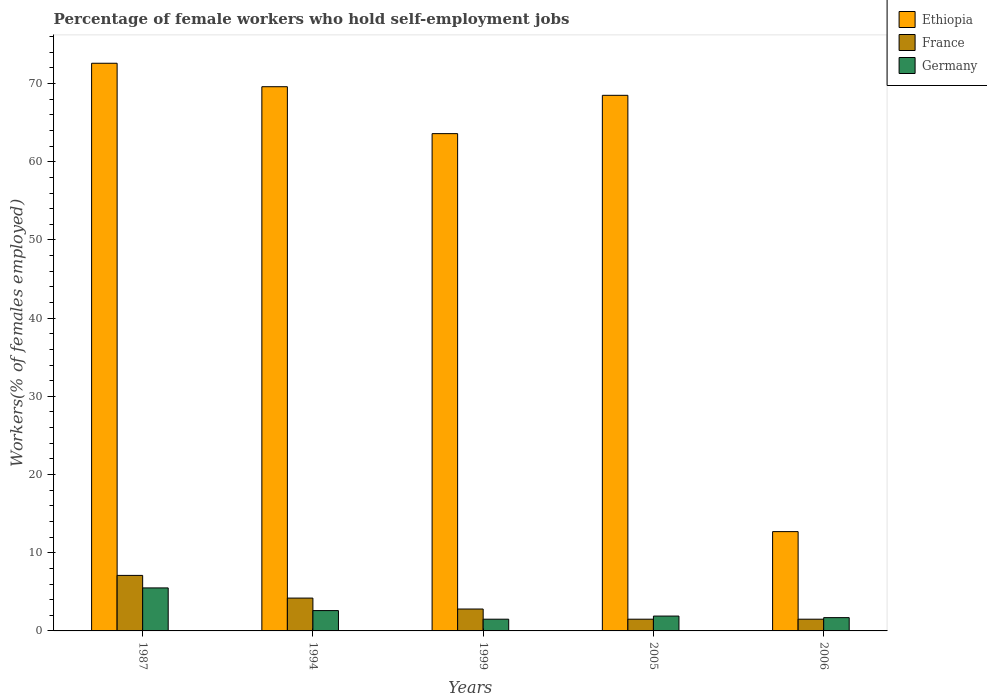How many groups of bars are there?
Offer a very short reply. 5. How many bars are there on the 4th tick from the left?
Make the answer very short. 3. How many bars are there on the 2nd tick from the right?
Offer a very short reply. 3. What is the percentage of self-employed female workers in Germany in 2005?
Provide a succinct answer. 1.9. Across all years, what is the maximum percentage of self-employed female workers in Ethiopia?
Keep it short and to the point. 72.6. Across all years, what is the minimum percentage of self-employed female workers in Ethiopia?
Provide a succinct answer. 12.7. In which year was the percentage of self-employed female workers in Ethiopia maximum?
Provide a succinct answer. 1987. In which year was the percentage of self-employed female workers in Germany minimum?
Provide a succinct answer. 1999. What is the total percentage of self-employed female workers in Germany in the graph?
Your answer should be very brief. 13.2. What is the difference between the percentage of self-employed female workers in France in 1994 and that in 2006?
Provide a succinct answer. 2.7. What is the difference between the percentage of self-employed female workers in Germany in 2006 and the percentage of self-employed female workers in Ethiopia in 1999?
Your answer should be compact. -61.9. What is the average percentage of self-employed female workers in Germany per year?
Your response must be concise. 2.64. In the year 1999, what is the difference between the percentage of self-employed female workers in Germany and percentage of self-employed female workers in Ethiopia?
Your answer should be compact. -62.1. What is the ratio of the percentage of self-employed female workers in Germany in 2005 to that in 2006?
Keep it short and to the point. 1.12. Is the percentage of self-employed female workers in Ethiopia in 1987 less than that in 1994?
Give a very brief answer. No. What is the difference between the highest and the second highest percentage of self-employed female workers in France?
Provide a short and direct response. 2.9. What is the difference between the highest and the lowest percentage of self-employed female workers in Germany?
Provide a short and direct response. 4. What does the 1st bar from the left in 2005 represents?
Your answer should be compact. Ethiopia. What does the 1st bar from the right in 1987 represents?
Give a very brief answer. Germany. What is the difference between two consecutive major ticks on the Y-axis?
Offer a very short reply. 10. Are the values on the major ticks of Y-axis written in scientific E-notation?
Provide a short and direct response. No. Does the graph contain any zero values?
Offer a very short reply. No. Does the graph contain grids?
Provide a succinct answer. No. How many legend labels are there?
Your answer should be very brief. 3. What is the title of the graph?
Give a very brief answer. Percentage of female workers who hold self-employment jobs. Does "Qatar" appear as one of the legend labels in the graph?
Your answer should be very brief. No. What is the label or title of the Y-axis?
Your response must be concise. Workers(% of females employed). What is the Workers(% of females employed) in Ethiopia in 1987?
Provide a succinct answer. 72.6. What is the Workers(% of females employed) of France in 1987?
Your response must be concise. 7.1. What is the Workers(% of females employed) of Germany in 1987?
Provide a short and direct response. 5.5. What is the Workers(% of females employed) of Ethiopia in 1994?
Your answer should be compact. 69.6. What is the Workers(% of females employed) in France in 1994?
Offer a very short reply. 4.2. What is the Workers(% of females employed) in Germany in 1994?
Offer a very short reply. 2.6. What is the Workers(% of females employed) in Ethiopia in 1999?
Provide a short and direct response. 63.6. What is the Workers(% of females employed) in France in 1999?
Keep it short and to the point. 2.8. What is the Workers(% of females employed) in Germany in 1999?
Provide a succinct answer. 1.5. What is the Workers(% of females employed) in Ethiopia in 2005?
Your response must be concise. 68.5. What is the Workers(% of females employed) in France in 2005?
Your response must be concise. 1.5. What is the Workers(% of females employed) of Germany in 2005?
Your response must be concise. 1.9. What is the Workers(% of females employed) in Ethiopia in 2006?
Offer a terse response. 12.7. What is the Workers(% of females employed) of France in 2006?
Your answer should be very brief. 1.5. What is the Workers(% of females employed) in Germany in 2006?
Provide a succinct answer. 1.7. Across all years, what is the maximum Workers(% of females employed) in Ethiopia?
Your response must be concise. 72.6. Across all years, what is the maximum Workers(% of females employed) of France?
Keep it short and to the point. 7.1. Across all years, what is the maximum Workers(% of females employed) in Germany?
Your answer should be compact. 5.5. Across all years, what is the minimum Workers(% of females employed) of Ethiopia?
Provide a short and direct response. 12.7. Across all years, what is the minimum Workers(% of females employed) of Germany?
Make the answer very short. 1.5. What is the total Workers(% of females employed) in Ethiopia in the graph?
Ensure brevity in your answer.  287. What is the total Workers(% of females employed) in Germany in the graph?
Provide a succinct answer. 13.2. What is the difference between the Workers(% of females employed) in Ethiopia in 1987 and that in 1994?
Offer a very short reply. 3. What is the difference between the Workers(% of females employed) in France in 1987 and that in 1994?
Provide a succinct answer. 2.9. What is the difference between the Workers(% of females employed) of Ethiopia in 1987 and that in 1999?
Keep it short and to the point. 9. What is the difference between the Workers(% of females employed) of Germany in 1987 and that in 2005?
Your answer should be very brief. 3.6. What is the difference between the Workers(% of females employed) of Ethiopia in 1987 and that in 2006?
Keep it short and to the point. 59.9. What is the difference between the Workers(% of females employed) in France in 1987 and that in 2006?
Provide a short and direct response. 5.6. What is the difference between the Workers(% of females employed) of France in 1994 and that in 1999?
Offer a terse response. 1.4. What is the difference between the Workers(% of females employed) in Ethiopia in 1994 and that in 2005?
Provide a succinct answer. 1.1. What is the difference between the Workers(% of females employed) of Germany in 1994 and that in 2005?
Your answer should be compact. 0.7. What is the difference between the Workers(% of females employed) of Ethiopia in 1994 and that in 2006?
Your answer should be compact. 56.9. What is the difference between the Workers(% of females employed) of France in 1994 and that in 2006?
Make the answer very short. 2.7. What is the difference between the Workers(% of females employed) in Ethiopia in 1999 and that in 2006?
Offer a very short reply. 50.9. What is the difference between the Workers(% of females employed) of France in 1999 and that in 2006?
Offer a very short reply. 1.3. What is the difference between the Workers(% of females employed) of Germany in 1999 and that in 2006?
Your answer should be very brief. -0.2. What is the difference between the Workers(% of females employed) in Ethiopia in 2005 and that in 2006?
Ensure brevity in your answer.  55.8. What is the difference between the Workers(% of females employed) of Germany in 2005 and that in 2006?
Offer a terse response. 0.2. What is the difference between the Workers(% of females employed) in Ethiopia in 1987 and the Workers(% of females employed) in France in 1994?
Your answer should be very brief. 68.4. What is the difference between the Workers(% of females employed) of Ethiopia in 1987 and the Workers(% of females employed) of Germany in 1994?
Ensure brevity in your answer.  70. What is the difference between the Workers(% of females employed) of France in 1987 and the Workers(% of females employed) of Germany in 1994?
Offer a very short reply. 4.5. What is the difference between the Workers(% of females employed) in Ethiopia in 1987 and the Workers(% of females employed) in France in 1999?
Your response must be concise. 69.8. What is the difference between the Workers(% of females employed) in Ethiopia in 1987 and the Workers(% of females employed) in Germany in 1999?
Your answer should be compact. 71.1. What is the difference between the Workers(% of females employed) in Ethiopia in 1987 and the Workers(% of females employed) in France in 2005?
Provide a short and direct response. 71.1. What is the difference between the Workers(% of females employed) in Ethiopia in 1987 and the Workers(% of females employed) in Germany in 2005?
Your answer should be very brief. 70.7. What is the difference between the Workers(% of females employed) in France in 1987 and the Workers(% of females employed) in Germany in 2005?
Make the answer very short. 5.2. What is the difference between the Workers(% of females employed) in Ethiopia in 1987 and the Workers(% of females employed) in France in 2006?
Offer a terse response. 71.1. What is the difference between the Workers(% of females employed) in Ethiopia in 1987 and the Workers(% of females employed) in Germany in 2006?
Your answer should be very brief. 70.9. What is the difference between the Workers(% of females employed) in Ethiopia in 1994 and the Workers(% of females employed) in France in 1999?
Your response must be concise. 66.8. What is the difference between the Workers(% of females employed) in Ethiopia in 1994 and the Workers(% of females employed) in Germany in 1999?
Your answer should be compact. 68.1. What is the difference between the Workers(% of females employed) of France in 1994 and the Workers(% of females employed) of Germany in 1999?
Make the answer very short. 2.7. What is the difference between the Workers(% of females employed) in Ethiopia in 1994 and the Workers(% of females employed) in France in 2005?
Provide a short and direct response. 68.1. What is the difference between the Workers(% of females employed) in Ethiopia in 1994 and the Workers(% of females employed) in Germany in 2005?
Offer a very short reply. 67.7. What is the difference between the Workers(% of females employed) in Ethiopia in 1994 and the Workers(% of females employed) in France in 2006?
Your answer should be very brief. 68.1. What is the difference between the Workers(% of females employed) of Ethiopia in 1994 and the Workers(% of females employed) of Germany in 2006?
Keep it short and to the point. 67.9. What is the difference between the Workers(% of females employed) of Ethiopia in 1999 and the Workers(% of females employed) of France in 2005?
Ensure brevity in your answer.  62.1. What is the difference between the Workers(% of females employed) of Ethiopia in 1999 and the Workers(% of females employed) of Germany in 2005?
Make the answer very short. 61.7. What is the difference between the Workers(% of females employed) of France in 1999 and the Workers(% of females employed) of Germany in 2005?
Make the answer very short. 0.9. What is the difference between the Workers(% of females employed) of Ethiopia in 1999 and the Workers(% of females employed) of France in 2006?
Offer a terse response. 62.1. What is the difference between the Workers(% of females employed) of Ethiopia in 1999 and the Workers(% of females employed) of Germany in 2006?
Ensure brevity in your answer.  61.9. What is the difference between the Workers(% of females employed) in Ethiopia in 2005 and the Workers(% of females employed) in France in 2006?
Your response must be concise. 67. What is the difference between the Workers(% of females employed) of Ethiopia in 2005 and the Workers(% of females employed) of Germany in 2006?
Ensure brevity in your answer.  66.8. What is the average Workers(% of females employed) in Ethiopia per year?
Your response must be concise. 57.4. What is the average Workers(% of females employed) of France per year?
Keep it short and to the point. 3.42. What is the average Workers(% of females employed) of Germany per year?
Ensure brevity in your answer.  2.64. In the year 1987, what is the difference between the Workers(% of females employed) of Ethiopia and Workers(% of females employed) of France?
Ensure brevity in your answer.  65.5. In the year 1987, what is the difference between the Workers(% of females employed) of Ethiopia and Workers(% of females employed) of Germany?
Your answer should be very brief. 67.1. In the year 1994, what is the difference between the Workers(% of females employed) in Ethiopia and Workers(% of females employed) in France?
Ensure brevity in your answer.  65.4. In the year 1994, what is the difference between the Workers(% of females employed) in Ethiopia and Workers(% of females employed) in Germany?
Keep it short and to the point. 67. In the year 1999, what is the difference between the Workers(% of females employed) of Ethiopia and Workers(% of females employed) of France?
Offer a very short reply. 60.8. In the year 1999, what is the difference between the Workers(% of females employed) in Ethiopia and Workers(% of females employed) in Germany?
Offer a very short reply. 62.1. In the year 1999, what is the difference between the Workers(% of females employed) of France and Workers(% of females employed) of Germany?
Your response must be concise. 1.3. In the year 2005, what is the difference between the Workers(% of females employed) of Ethiopia and Workers(% of females employed) of France?
Make the answer very short. 67. In the year 2005, what is the difference between the Workers(% of females employed) of Ethiopia and Workers(% of females employed) of Germany?
Offer a very short reply. 66.6. In the year 2005, what is the difference between the Workers(% of females employed) in France and Workers(% of females employed) in Germany?
Make the answer very short. -0.4. In the year 2006, what is the difference between the Workers(% of females employed) of Ethiopia and Workers(% of females employed) of France?
Ensure brevity in your answer.  11.2. In the year 2006, what is the difference between the Workers(% of females employed) of Ethiopia and Workers(% of females employed) of Germany?
Give a very brief answer. 11. What is the ratio of the Workers(% of females employed) in Ethiopia in 1987 to that in 1994?
Provide a short and direct response. 1.04. What is the ratio of the Workers(% of females employed) of France in 1987 to that in 1994?
Keep it short and to the point. 1.69. What is the ratio of the Workers(% of females employed) in Germany in 1987 to that in 1994?
Your response must be concise. 2.12. What is the ratio of the Workers(% of females employed) of Ethiopia in 1987 to that in 1999?
Offer a very short reply. 1.14. What is the ratio of the Workers(% of females employed) in France in 1987 to that in 1999?
Ensure brevity in your answer.  2.54. What is the ratio of the Workers(% of females employed) of Germany in 1987 to that in 1999?
Ensure brevity in your answer.  3.67. What is the ratio of the Workers(% of females employed) of Ethiopia in 1987 to that in 2005?
Give a very brief answer. 1.06. What is the ratio of the Workers(% of females employed) of France in 1987 to that in 2005?
Your answer should be compact. 4.73. What is the ratio of the Workers(% of females employed) in Germany in 1987 to that in 2005?
Your response must be concise. 2.89. What is the ratio of the Workers(% of females employed) in Ethiopia in 1987 to that in 2006?
Provide a succinct answer. 5.72. What is the ratio of the Workers(% of females employed) of France in 1987 to that in 2006?
Offer a very short reply. 4.73. What is the ratio of the Workers(% of females employed) of Germany in 1987 to that in 2006?
Your response must be concise. 3.24. What is the ratio of the Workers(% of females employed) of Ethiopia in 1994 to that in 1999?
Give a very brief answer. 1.09. What is the ratio of the Workers(% of females employed) in France in 1994 to that in 1999?
Provide a succinct answer. 1.5. What is the ratio of the Workers(% of females employed) of Germany in 1994 to that in 1999?
Your answer should be compact. 1.73. What is the ratio of the Workers(% of females employed) of Ethiopia in 1994 to that in 2005?
Your answer should be compact. 1.02. What is the ratio of the Workers(% of females employed) of France in 1994 to that in 2005?
Your answer should be very brief. 2.8. What is the ratio of the Workers(% of females employed) of Germany in 1994 to that in 2005?
Provide a succinct answer. 1.37. What is the ratio of the Workers(% of females employed) in Ethiopia in 1994 to that in 2006?
Your answer should be compact. 5.48. What is the ratio of the Workers(% of females employed) in France in 1994 to that in 2006?
Your answer should be compact. 2.8. What is the ratio of the Workers(% of females employed) in Germany in 1994 to that in 2006?
Your answer should be very brief. 1.53. What is the ratio of the Workers(% of females employed) of Ethiopia in 1999 to that in 2005?
Provide a succinct answer. 0.93. What is the ratio of the Workers(% of females employed) of France in 1999 to that in 2005?
Your answer should be compact. 1.87. What is the ratio of the Workers(% of females employed) in Germany in 1999 to that in 2005?
Offer a terse response. 0.79. What is the ratio of the Workers(% of females employed) of Ethiopia in 1999 to that in 2006?
Provide a succinct answer. 5.01. What is the ratio of the Workers(% of females employed) of France in 1999 to that in 2006?
Provide a short and direct response. 1.87. What is the ratio of the Workers(% of females employed) of Germany in 1999 to that in 2006?
Keep it short and to the point. 0.88. What is the ratio of the Workers(% of females employed) in Ethiopia in 2005 to that in 2006?
Offer a terse response. 5.39. What is the ratio of the Workers(% of females employed) of France in 2005 to that in 2006?
Provide a short and direct response. 1. What is the ratio of the Workers(% of females employed) of Germany in 2005 to that in 2006?
Offer a very short reply. 1.12. What is the difference between the highest and the second highest Workers(% of females employed) of Ethiopia?
Your response must be concise. 3. What is the difference between the highest and the second highest Workers(% of females employed) of France?
Make the answer very short. 2.9. What is the difference between the highest and the second highest Workers(% of females employed) in Germany?
Make the answer very short. 2.9. What is the difference between the highest and the lowest Workers(% of females employed) of Ethiopia?
Provide a short and direct response. 59.9. What is the difference between the highest and the lowest Workers(% of females employed) of Germany?
Provide a succinct answer. 4. 